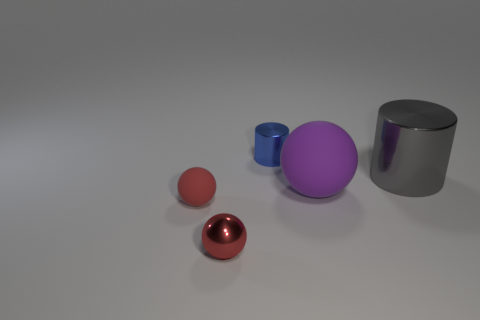How many other things are there of the same shape as the red matte thing?
Provide a succinct answer. 2. Does the cylinder that is on the left side of the gray metallic cylinder have the same size as the purple rubber object?
Your response must be concise. No. Are there more big gray shiny objects that are left of the red matte sphere than big purple matte cylinders?
Offer a very short reply. No. There is a small red object that is in front of the tiny red matte object; what number of shiny objects are on the right side of it?
Your answer should be very brief. 2. Is the number of gray things that are left of the large metallic cylinder less than the number of small blue matte objects?
Offer a terse response. No. Is there a rubber object behind the ball that is left of the ball that is in front of the red matte ball?
Keep it short and to the point. Yes. Does the large sphere have the same material as the sphere that is to the left of the small red metallic ball?
Offer a very short reply. Yes. There is a small metal thing in front of the red ball behind the small red metal sphere; what color is it?
Your answer should be compact. Red. Is there a small rubber ball that has the same color as the shiny sphere?
Keep it short and to the point. Yes. There is a metallic thing that is on the right side of the object that is behind the shiny object that is on the right side of the purple object; what size is it?
Keep it short and to the point. Large. 